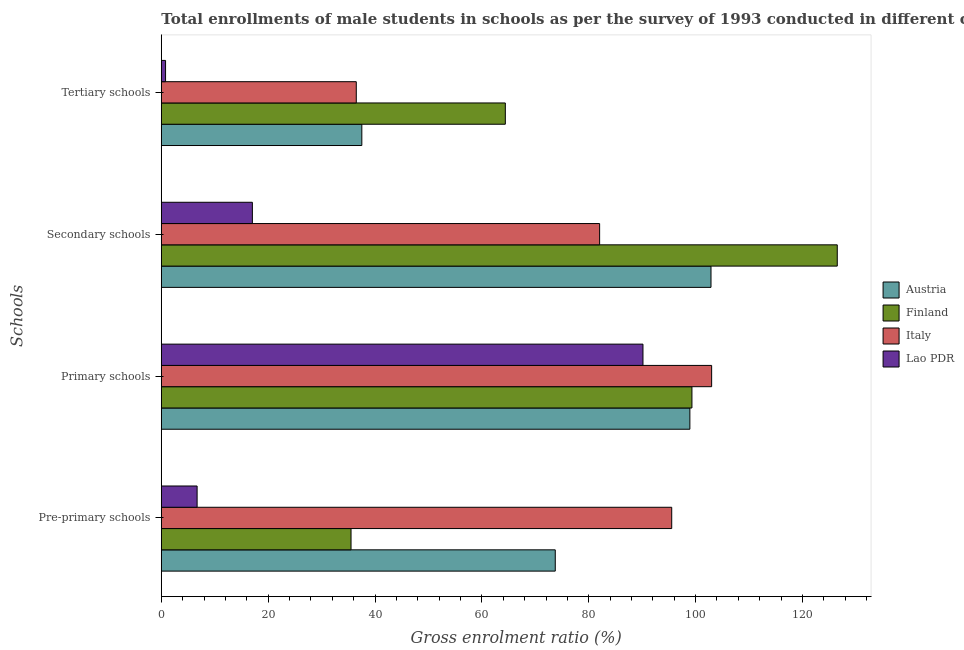How many groups of bars are there?
Offer a very short reply. 4. Are the number of bars per tick equal to the number of legend labels?
Offer a terse response. Yes. Are the number of bars on each tick of the Y-axis equal?
Your answer should be very brief. Yes. What is the label of the 1st group of bars from the top?
Your answer should be compact. Tertiary schools. What is the gross enrolment ratio(male) in secondary schools in Finland?
Your answer should be compact. 126.52. Across all countries, what is the maximum gross enrolment ratio(male) in secondary schools?
Ensure brevity in your answer.  126.52. Across all countries, what is the minimum gross enrolment ratio(male) in tertiary schools?
Your answer should be compact. 0.8. In which country was the gross enrolment ratio(male) in pre-primary schools minimum?
Your response must be concise. Lao PDR. What is the total gross enrolment ratio(male) in tertiary schools in the graph?
Give a very brief answer. 139.2. What is the difference between the gross enrolment ratio(male) in pre-primary schools in Austria and that in Lao PDR?
Provide a short and direct response. 67.04. What is the difference between the gross enrolment ratio(male) in primary schools in Finland and the gross enrolment ratio(male) in secondary schools in Italy?
Offer a very short reply. 17.28. What is the average gross enrolment ratio(male) in tertiary schools per country?
Offer a very short reply. 34.8. What is the difference between the gross enrolment ratio(male) in pre-primary schools and gross enrolment ratio(male) in primary schools in Finland?
Keep it short and to the point. -63.81. What is the ratio of the gross enrolment ratio(male) in secondary schools in Finland to that in Italy?
Your answer should be compact. 1.54. Is the gross enrolment ratio(male) in pre-primary schools in Lao PDR less than that in Finland?
Keep it short and to the point. Yes. Is the difference between the gross enrolment ratio(male) in pre-primary schools in Finland and Lao PDR greater than the difference between the gross enrolment ratio(male) in tertiary schools in Finland and Lao PDR?
Ensure brevity in your answer.  No. What is the difference between the highest and the second highest gross enrolment ratio(male) in secondary schools?
Give a very brief answer. 23.63. What is the difference between the highest and the lowest gross enrolment ratio(male) in primary schools?
Offer a very short reply. 12.85. Is the sum of the gross enrolment ratio(male) in primary schools in Italy and Finland greater than the maximum gross enrolment ratio(male) in pre-primary schools across all countries?
Your response must be concise. Yes. What does the 1st bar from the top in Secondary schools represents?
Provide a succinct answer. Lao PDR. What does the 4th bar from the bottom in Secondary schools represents?
Make the answer very short. Lao PDR. How many bars are there?
Offer a terse response. 16. Are all the bars in the graph horizontal?
Make the answer very short. Yes. How many countries are there in the graph?
Give a very brief answer. 4. What is the difference between two consecutive major ticks on the X-axis?
Offer a very short reply. 20. Does the graph contain any zero values?
Your response must be concise. No. How many legend labels are there?
Your answer should be compact. 4. How are the legend labels stacked?
Provide a short and direct response. Vertical. What is the title of the graph?
Your answer should be compact. Total enrollments of male students in schools as per the survey of 1993 conducted in different countries. What is the label or title of the Y-axis?
Offer a terse response. Schools. What is the Gross enrolment ratio (%) in Austria in Pre-primary schools?
Ensure brevity in your answer.  73.73. What is the Gross enrolment ratio (%) of Finland in Pre-primary schools?
Provide a short and direct response. 35.51. What is the Gross enrolment ratio (%) in Italy in Pre-primary schools?
Provide a succinct answer. 95.53. What is the Gross enrolment ratio (%) of Lao PDR in Pre-primary schools?
Provide a succinct answer. 6.7. What is the Gross enrolment ratio (%) of Austria in Primary schools?
Provide a succinct answer. 98.93. What is the Gross enrolment ratio (%) in Finland in Primary schools?
Offer a terse response. 99.31. What is the Gross enrolment ratio (%) of Italy in Primary schools?
Keep it short and to the point. 103. What is the Gross enrolment ratio (%) in Lao PDR in Primary schools?
Provide a succinct answer. 90.15. What is the Gross enrolment ratio (%) of Austria in Secondary schools?
Offer a terse response. 102.88. What is the Gross enrolment ratio (%) in Finland in Secondary schools?
Your answer should be compact. 126.52. What is the Gross enrolment ratio (%) of Italy in Secondary schools?
Your answer should be compact. 82.04. What is the Gross enrolment ratio (%) in Lao PDR in Secondary schools?
Make the answer very short. 17.04. What is the Gross enrolment ratio (%) in Austria in Tertiary schools?
Offer a terse response. 37.53. What is the Gross enrolment ratio (%) of Finland in Tertiary schools?
Keep it short and to the point. 64.39. What is the Gross enrolment ratio (%) in Italy in Tertiary schools?
Provide a succinct answer. 36.49. What is the Gross enrolment ratio (%) in Lao PDR in Tertiary schools?
Provide a short and direct response. 0.8. Across all Schools, what is the maximum Gross enrolment ratio (%) of Austria?
Provide a succinct answer. 102.88. Across all Schools, what is the maximum Gross enrolment ratio (%) in Finland?
Ensure brevity in your answer.  126.52. Across all Schools, what is the maximum Gross enrolment ratio (%) of Italy?
Offer a very short reply. 103. Across all Schools, what is the maximum Gross enrolment ratio (%) in Lao PDR?
Your answer should be compact. 90.15. Across all Schools, what is the minimum Gross enrolment ratio (%) of Austria?
Ensure brevity in your answer.  37.53. Across all Schools, what is the minimum Gross enrolment ratio (%) of Finland?
Provide a succinct answer. 35.51. Across all Schools, what is the minimum Gross enrolment ratio (%) in Italy?
Offer a very short reply. 36.49. Across all Schools, what is the minimum Gross enrolment ratio (%) in Lao PDR?
Offer a terse response. 0.8. What is the total Gross enrolment ratio (%) in Austria in the graph?
Offer a terse response. 313.07. What is the total Gross enrolment ratio (%) in Finland in the graph?
Your response must be concise. 325.73. What is the total Gross enrolment ratio (%) of Italy in the graph?
Your response must be concise. 317.06. What is the total Gross enrolment ratio (%) in Lao PDR in the graph?
Provide a short and direct response. 114.68. What is the difference between the Gross enrolment ratio (%) in Austria in Pre-primary schools and that in Primary schools?
Ensure brevity in your answer.  -25.19. What is the difference between the Gross enrolment ratio (%) in Finland in Pre-primary schools and that in Primary schools?
Your answer should be very brief. -63.81. What is the difference between the Gross enrolment ratio (%) of Italy in Pre-primary schools and that in Primary schools?
Make the answer very short. -7.47. What is the difference between the Gross enrolment ratio (%) in Lao PDR in Pre-primary schools and that in Primary schools?
Offer a terse response. -83.45. What is the difference between the Gross enrolment ratio (%) in Austria in Pre-primary schools and that in Secondary schools?
Your answer should be compact. -29.15. What is the difference between the Gross enrolment ratio (%) of Finland in Pre-primary schools and that in Secondary schools?
Offer a terse response. -91.01. What is the difference between the Gross enrolment ratio (%) of Italy in Pre-primary schools and that in Secondary schools?
Keep it short and to the point. 13.49. What is the difference between the Gross enrolment ratio (%) in Lao PDR in Pre-primary schools and that in Secondary schools?
Your response must be concise. -10.34. What is the difference between the Gross enrolment ratio (%) in Austria in Pre-primary schools and that in Tertiary schools?
Ensure brevity in your answer.  36.21. What is the difference between the Gross enrolment ratio (%) of Finland in Pre-primary schools and that in Tertiary schools?
Provide a succinct answer. -28.88. What is the difference between the Gross enrolment ratio (%) in Italy in Pre-primary schools and that in Tertiary schools?
Keep it short and to the point. 59.04. What is the difference between the Gross enrolment ratio (%) of Lao PDR in Pre-primary schools and that in Tertiary schools?
Provide a succinct answer. 5.9. What is the difference between the Gross enrolment ratio (%) of Austria in Primary schools and that in Secondary schools?
Offer a very short reply. -3.95. What is the difference between the Gross enrolment ratio (%) in Finland in Primary schools and that in Secondary schools?
Make the answer very short. -27.2. What is the difference between the Gross enrolment ratio (%) of Italy in Primary schools and that in Secondary schools?
Offer a terse response. 20.96. What is the difference between the Gross enrolment ratio (%) of Lao PDR in Primary schools and that in Secondary schools?
Your response must be concise. 73.11. What is the difference between the Gross enrolment ratio (%) in Austria in Primary schools and that in Tertiary schools?
Ensure brevity in your answer.  61.4. What is the difference between the Gross enrolment ratio (%) of Finland in Primary schools and that in Tertiary schools?
Your response must be concise. 34.93. What is the difference between the Gross enrolment ratio (%) in Italy in Primary schools and that in Tertiary schools?
Provide a succinct answer. 66.51. What is the difference between the Gross enrolment ratio (%) of Lao PDR in Primary schools and that in Tertiary schools?
Provide a short and direct response. 89.35. What is the difference between the Gross enrolment ratio (%) of Austria in Secondary schools and that in Tertiary schools?
Offer a terse response. 65.35. What is the difference between the Gross enrolment ratio (%) of Finland in Secondary schools and that in Tertiary schools?
Give a very brief answer. 62.13. What is the difference between the Gross enrolment ratio (%) in Italy in Secondary schools and that in Tertiary schools?
Ensure brevity in your answer.  45.55. What is the difference between the Gross enrolment ratio (%) in Lao PDR in Secondary schools and that in Tertiary schools?
Provide a short and direct response. 16.25. What is the difference between the Gross enrolment ratio (%) in Austria in Pre-primary schools and the Gross enrolment ratio (%) in Finland in Primary schools?
Ensure brevity in your answer.  -25.58. What is the difference between the Gross enrolment ratio (%) in Austria in Pre-primary schools and the Gross enrolment ratio (%) in Italy in Primary schools?
Provide a succinct answer. -29.27. What is the difference between the Gross enrolment ratio (%) of Austria in Pre-primary schools and the Gross enrolment ratio (%) of Lao PDR in Primary schools?
Offer a very short reply. -16.41. What is the difference between the Gross enrolment ratio (%) of Finland in Pre-primary schools and the Gross enrolment ratio (%) of Italy in Primary schools?
Offer a very short reply. -67.49. What is the difference between the Gross enrolment ratio (%) of Finland in Pre-primary schools and the Gross enrolment ratio (%) of Lao PDR in Primary schools?
Your answer should be compact. -54.64. What is the difference between the Gross enrolment ratio (%) in Italy in Pre-primary schools and the Gross enrolment ratio (%) in Lao PDR in Primary schools?
Provide a succinct answer. 5.38. What is the difference between the Gross enrolment ratio (%) of Austria in Pre-primary schools and the Gross enrolment ratio (%) of Finland in Secondary schools?
Keep it short and to the point. -52.78. What is the difference between the Gross enrolment ratio (%) of Austria in Pre-primary schools and the Gross enrolment ratio (%) of Italy in Secondary schools?
Keep it short and to the point. -8.3. What is the difference between the Gross enrolment ratio (%) in Austria in Pre-primary schools and the Gross enrolment ratio (%) in Lao PDR in Secondary schools?
Your answer should be compact. 56.69. What is the difference between the Gross enrolment ratio (%) in Finland in Pre-primary schools and the Gross enrolment ratio (%) in Italy in Secondary schools?
Your answer should be compact. -46.53. What is the difference between the Gross enrolment ratio (%) of Finland in Pre-primary schools and the Gross enrolment ratio (%) of Lao PDR in Secondary schools?
Your answer should be very brief. 18.47. What is the difference between the Gross enrolment ratio (%) in Italy in Pre-primary schools and the Gross enrolment ratio (%) in Lao PDR in Secondary schools?
Provide a succinct answer. 78.49. What is the difference between the Gross enrolment ratio (%) in Austria in Pre-primary schools and the Gross enrolment ratio (%) in Finland in Tertiary schools?
Give a very brief answer. 9.35. What is the difference between the Gross enrolment ratio (%) in Austria in Pre-primary schools and the Gross enrolment ratio (%) in Italy in Tertiary schools?
Offer a terse response. 37.24. What is the difference between the Gross enrolment ratio (%) in Austria in Pre-primary schools and the Gross enrolment ratio (%) in Lao PDR in Tertiary schools?
Offer a very short reply. 72.94. What is the difference between the Gross enrolment ratio (%) in Finland in Pre-primary schools and the Gross enrolment ratio (%) in Italy in Tertiary schools?
Give a very brief answer. -0.98. What is the difference between the Gross enrolment ratio (%) of Finland in Pre-primary schools and the Gross enrolment ratio (%) of Lao PDR in Tertiary schools?
Ensure brevity in your answer.  34.71. What is the difference between the Gross enrolment ratio (%) of Italy in Pre-primary schools and the Gross enrolment ratio (%) of Lao PDR in Tertiary schools?
Offer a terse response. 94.73. What is the difference between the Gross enrolment ratio (%) of Austria in Primary schools and the Gross enrolment ratio (%) of Finland in Secondary schools?
Provide a short and direct response. -27.59. What is the difference between the Gross enrolment ratio (%) in Austria in Primary schools and the Gross enrolment ratio (%) in Italy in Secondary schools?
Provide a short and direct response. 16.89. What is the difference between the Gross enrolment ratio (%) in Austria in Primary schools and the Gross enrolment ratio (%) in Lao PDR in Secondary schools?
Your answer should be compact. 81.89. What is the difference between the Gross enrolment ratio (%) in Finland in Primary schools and the Gross enrolment ratio (%) in Italy in Secondary schools?
Your response must be concise. 17.28. What is the difference between the Gross enrolment ratio (%) in Finland in Primary schools and the Gross enrolment ratio (%) in Lao PDR in Secondary schools?
Your answer should be compact. 82.27. What is the difference between the Gross enrolment ratio (%) of Italy in Primary schools and the Gross enrolment ratio (%) of Lao PDR in Secondary schools?
Ensure brevity in your answer.  85.96. What is the difference between the Gross enrolment ratio (%) of Austria in Primary schools and the Gross enrolment ratio (%) of Finland in Tertiary schools?
Your response must be concise. 34.54. What is the difference between the Gross enrolment ratio (%) of Austria in Primary schools and the Gross enrolment ratio (%) of Italy in Tertiary schools?
Provide a succinct answer. 62.44. What is the difference between the Gross enrolment ratio (%) of Austria in Primary schools and the Gross enrolment ratio (%) of Lao PDR in Tertiary schools?
Make the answer very short. 98.13. What is the difference between the Gross enrolment ratio (%) in Finland in Primary schools and the Gross enrolment ratio (%) in Italy in Tertiary schools?
Make the answer very short. 62.82. What is the difference between the Gross enrolment ratio (%) in Finland in Primary schools and the Gross enrolment ratio (%) in Lao PDR in Tertiary schools?
Ensure brevity in your answer.  98.52. What is the difference between the Gross enrolment ratio (%) of Italy in Primary schools and the Gross enrolment ratio (%) of Lao PDR in Tertiary schools?
Make the answer very short. 102.21. What is the difference between the Gross enrolment ratio (%) in Austria in Secondary schools and the Gross enrolment ratio (%) in Finland in Tertiary schools?
Make the answer very short. 38.49. What is the difference between the Gross enrolment ratio (%) of Austria in Secondary schools and the Gross enrolment ratio (%) of Italy in Tertiary schools?
Provide a short and direct response. 66.39. What is the difference between the Gross enrolment ratio (%) of Austria in Secondary schools and the Gross enrolment ratio (%) of Lao PDR in Tertiary schools?
Ensure brevity in your answer.  102.09. What is the difference between the Gross enrolment ratio (%) in Finland in Secondary schools and the Gross enrolment ratio (%) in Italy in Tertiary schools?
Keep it short and to the point. 90.03. What is the difference between the Gross enrolment ratio (%) of Finland in Secondary schools and the Gross enrolment ratio (%) of Lao PDR in Tertiary schools?
Keep it short and to the point. 125.72. What is the difference between the Gross enrolment ratio (%) in Italy in Secondary schools and the Gross enrolment ratio (%) in Lao PDR in Tertiary schools?
Your answer should be compact. 81.24. What is the average Gross enrolment ratio (%) in Austria per Schools?
Your answer should be very brief. 78.27. What is the average Gross enrolment ratio (%) of Finland per Schools?
Your response must be concise. 81.43. What is the average Gross enrolment ratio (%) of Italy per Schools?
Make the answer very short. 79.26. What is the average Gross enrolment ratio (%) of Lao PDR per Schools?
Give a very brief answer. 28.67. What is the difference between the Gross enrolment ratio (%) in Austria and Gross enrolment ratio (%) in Finland in Pre-primary schools?
Offer a very short reply. 38.23. What is the difference between the Gross enrolment ratio (%) in Austria and Gross enrolment ratio (%) in Italy in Pre-primary schools?
Your answer should be very brief. -21.79. What is the difference between the Gross enrolment ratio (%) of Austria and Gross enrolment ratio (%) of Lao PDR in Pre-primary schools?
Your response must be concise. 67.04. What is the difference between the Gross enrolment ratio (%) of Finland and Gross enrolment ratio (%) of Italy in Pre-primary schools?
Your response must be concise. -60.02. What is the difference between the Gross enrolment ratio (%) in Finland and Gross enrolment ratio (%) in Lao PDR in Pre-primary schools?
Give a very brief answer. 28.81. What is the difference between the Gross enrolment ratio (%) of Italy and Gross enrolment ratio (%) of Lao PDR in Pre-primary schools?
Your answer should be very brief. 88.83. What is the difference between the Gross enrolment ratio (%) in Austria and Gross enrolment ratio (%) in Finland in Primary schools?
Offer a very short reply. -0.39. What is the difference between the Gross enrolment ratio (%) in Austria and Gross enrolment ratio (%) in Italy in Primary schools?
Give a very brief answer. -4.07. What is the difference between the Gross enrolment ratio (%) of Austria and Gross enrolment ratio (%) of Lao PDR in Primary schools?
Your response must be concise. 8.78. What is the difference between the Gross enrolment ratio (%) of Finland and Gross enrolment ratio (%) of Italy in Primary schools?
Offer a very short reply. -3.69. What is the difference between the Gross enrolment ratio (%) of Finland and Gross enrolment ratio (%) of Lao PDR in Primary schools?
Provide a succinct answer. 9.17. What is the difference between the Gross enrolment ratio (%) in Italy and Gross enrolment ratio (%) in Lao PDR in Primary schools?
Provide a succinct answer. 12.85. What is the difference between the Gross enrolment ratio (%) of Austria and Gross enrolment ratio (%) of Finland in Secondary schools?
Your answer should be very brief. -23.63. What is the difference between the Gross enrolment ratio (%) of Austria and Gross enrolment ratio (%) of Italy in Secondary schools?
Ensure brevity in your answer.  20.84. What is the difference between the Gross enrolment ratio (%) in Austria and Gross enrolment ratio (%) in Lao PDR in Secondary schools?
Provide a succinct answer. 85.84. What is the difference between the Gross enrolment ratio (%) in Finland and Gross enrolment ratio (%) in Italy in Secondary schools?
Give a very brief answer. 44.48. What is the difference between the Gross enrolment ratio (%) of Finland and Gross enrolment ratio (%) of Lao PDR in Secondary schools?
Make the answer very short. 109.47. What is the difference between the Gross enrolment ratio (%) in Italy and Gross enrolment ratio (%) in Lao PDR in Secondary schools?
Provide a short and direct response. 65. What is the difference between the Gross enrolment ratio (%) of Austria and Gross enrolment ratio (%) of Finland in Tertiary schools?
Make the answer very short. -26.86. What is the difference between the Gross enrolment ratio (%) of Austria and Gross enrolment ratio (%) of Italy in Tertiary schools?
Your response must be concise. 1.04. What is the difference between the Gross enrolment ratio (%) of Austria and Gross enrolment ratio (%) of Lao PDR in Tertiary schools?
Make the answer very short. 36.73. What is the difference between the Gross enrolment ratio (%) of Finland and Gross enrolment ratio (%) of Italy in Tertiary schools?
Give a very brief answer. 27.9. What is the difference between the Gross enrolment ratio (%) in Finland and Gross enrolment ratio (%) in Lao PDR in Tertiary schools?
Your answer should be compact. 63.59. What is the difference between the Gross enrolment ratio (%) of Italy and Gross enrolment ratio (%) of Lao PDR in Tertiary schools?
Ensure brevity in your answer.  35.69. What is the ratio of the Gross enrolment ratio (%) in Austria in Pre-primary schools to that in Primary schools?
Provide a short and direct response. 0.75. What is the ratio of the Gross enrolment ratio (%) in Finland in Pre-primary schools to that in Primary schools?
Provide a succinct answer. 0.36. What is the ratio of the Gross enrolment ratio (%) of Italy in Pre-primary schools to that in Primary schools?
Ensure brevity in your answer.  0.93. What is the ratio of the Gross enrolment ratio (%) of Lao PDR in Pre-primary schools to that in Primary schools?
Offer a very short reply. 0.07. What is the ratio of the Gross enrolment ratio (%) in Austria in Pre-primary schools to that in Secondary schools?
Offer a terse response. 0.72. What is the ratio of the Gross enrolment ratio (%) in Finland in Pre-primary schools to that in Secondary schools?
Your answer should be compact. 0.28. What is the ratio of the Gross enrolment ratio (%) in Italy in Pre-primary schools to that in Secondary schools?
Provide a succinct answer. 1.16. What is the ratio of the Gross enrolment ratio (%) of Lao PDR in Pre-primary schools to that in Secondary schools?
Provide a succinct answer. 0.39. What is the ratio of the Gross enrolment ratio (%) in Austria in Pre-primary schools to that in Tertiary schools?
Your response must be concise. 1.96. What is the ratio of the Gross enrolment ratio (%) of Finland in Pre-primary schools to that in Tertiary schools?
Ensure brevity in your answer.  0.55. What is the ratio of the Gross enrolment ratio (%) of Italy in Pre-primary schools to that in Tertiary schools?
Keep it short and to the point. 2.62. What is the ratio of the Gross enrolment ratio (%) in Lao PDR in Pre-primary schools to that in Tertiary schools?
Your answer should be very brief. 8.41. What is the ratio of the Gross enrolment ratio (%) in Austria in Primary schools to that in Secondary schools?
Provide a short and direct response. 0.96. What is the ratio of the Gross enrolment ratio (%) in Finland in Primary schools to that in Secondary schools?
Offer a terse response. 0.79. What is the ratio of the Gross enrolment ratio (%) in Italy in Primary schools to that in Secondary schools?
Ensure brevity in your answer.  1.26. What is the ratio of the Gross enrolment ratio (%) of Lao PDR in Primary schools to that in Secondary schools?
Make the answer very short. 5.29. What is the ratio of the Gross enrolment ratio (%) in Austria in Primary schools to that in Tertiary schools?
Give a very brief answer. 2.64. What is the ratio of the Gross enrolment ratio (%) in Finland in Primary schools to that in Tertiary schools?
Offer a very short reply. 1.54. What is the ratio of the Gross enrolment ratio (%) in Italy in Primary schools to that in Tertiary schools?
Give a very brief answer. 2.82. What is the ratio of the Gross enrolment ratio (%) of Lao PDR in Primary schools to that in Tertiary schools?
Give a very brief answer. 113.25. What is the ratio of the Gross enrolment ratio (%) in Austria in Secondary schools to that in Tertiary schools?
Your response must be concise. 2.74. What is the ratio of the Gross enrolment ratio (%) of Finland in Secondary schools to that in Tertiary schools?
Provide a short and direct response. 1.96. What is the ratio of the Gross enrolment ratio (%) of Italy in Secondary schools to that in Tertiary schools?
Give a very brief answer. 2.25. What is the ratio of the Gross enrolment ratio (%) of Lao PDR in Secondary schools to that in Tertiary schools?
Your answer should be compact. 21.41. What is the difference between the highest and the second highest Gross enrolment ratio (%) of Austria?
Offer a very short reply. 3.95. What is the difference between the highest and the second highest Gross enrolment ratio (%) in Finland?
Provide a short and direct response. 27.2. What is the difference between the highest and the second highest Gross enrolment ratio (%) in Italy?
Your answer should be very brief. 7.47. What is the difference between the highest and the second highest Gross enrolment ratio (%) of Lao PDR?
Make the answer very short. 73.11. What is the difference between the highest and the lowest Gross enrolment ratio (%) of Austria?
Ensure brevity in your answer.  65.35. What is the difference between the highest and the lowest Gross enrolment ratio (%) in Finland?
Give a very brief answer. 91.01. What is the difference between the highest and the lowest Gross enrolment ratio (%) in Italy?
Provide a short and direct response. 66.51. What is the difference between the highest and the lowest Gross enrolment ratio (%) of Lao PDR?
Offer a terse response. 89.35. 